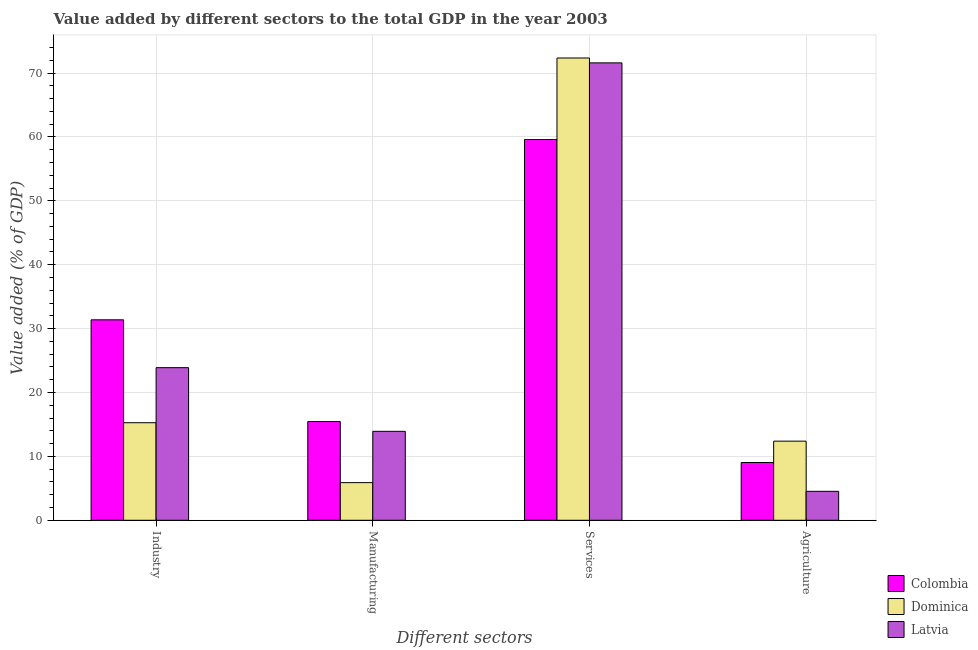How many groups of bars are there?
Your answer should be very brief. 4. How many bars are there on the 4th tick from the right?
Provide a short and direct response. 3. What is the label of the 3rd group of bars from the left?
Provide a short and direct response. Services. What is the value added by manufacturing sector in Dominica?
Give a very brief answer. 5.89. Across all countries, what is the maximum value added by services sector?
Your answer should be very brief. 72.35. Across all countries, what is the minimum value added by services sector?
Make the answer very short. 59.59. In which country was the value added by manufacturing sector maximum?
Your answer should be very brief. Colombia. In which country was the value added by manufacturing sector minimum?
Your response must be concise. Dominica. What is the total value added by manufacturing sector in the graph?
Offer a very short reply. 35.26. What is the difference between the value added by agricultural sector in Colombia and that in Dominica?
Your answer should be very brief. -3.34. What is the difference between the value added by services sector in Latvia and the value added by industrial sector in Colombia?
Your response must be concise. 40.21. What is the average value added by industrial sector per country?
Give a very brief answer. 23.51. What is the difference between the value added by services sector and value added by agricultural sector in Colombia?
Provide a succinct answer. 50.55. What is the ratio of the value added by agricultural sector in Colombia to that in Latvia?
Your answer should be very brief. 1.99. What is the difference between the highest and the second highest value added by services sector?
Make the answer very short. 0.76. What is the difference between the highest and the lowest value added by agricultural sector?
Ensure brevity in your answer.  7.85. In how many countries, is the value added by industrial sector greater than the average value added by industrial sector taken over all countries?
Give a very brief answer. 2. Is the sum of the value added by manufacturing sector in Colombia and Dominica greater than the maximum value added by agricultural sector across all countries?
Keep it short and to the point. Yes. What does the 2nd bar from the left in Industry represents?
Provide a short and direct response. Dominica. What does the 2nd bar from the right in Agriculture represents?
Make the answer very short. Dominica. Is it the case that in every country, the sum of the value added by industrial sector and value added by manufacturing sector is greater than the value added by services sector?
Give a very brief answer. No. How many bars are there?
Your answer should be very brief. 12. How many countries are there in the graph?
Provide a succinct answer. 3. What is the difference between two consecutive major ticks on the Y-axis?
Give a very brief answer. 10. Are the values on the major ticks of Y-axis written in scientific E-notation?
Ensure brevity in your answer.  No. Does the graph contain any zero values?
Offer a terse response. No. Does the graph contain grids?
Your answer should be compact. Yes. Where does the legend appear in the graph?
Your response must be concise. Bottom right. What is the title of the graph?
Provide a short and direct response. Value added by different sectors to the total GDP in the year 2003. Does "Lao PDR" appear as one of the legend labels in the graph?
Provide a succinct answer. No. What is the label or title of the X-axis?
Offer a terse response. Different sectors. What is the label or title of the Y-axis?
Keep it short and to the point. Value added (% of GDP). What is the Value added (% of GDP) of Colombia in Industry?
Give a very brief answer. 31.37. What is the Value added (% of GDP) of Dominica in Industry?
Your response must be concise. 15.27. What is the Value added (% of GDP) in Latvia in Industry?
Keep it short and to the point. 23.88. What is the Value added (% of GDP) in Colombia in Manufacturing?
Your answer should be very brief. 15.45. What is the Value added (% of GDP) of Dominica in Manufacturing?
Offer a terse response. 5.89. What is the Value added (% of GDP) in Latvia in Manufacturing?
Your answer should be compact. 13.92. What is the Value added (% of GDP) of Colombia in Services?
Provide a short and direct response. 59.59. What is the Value added (% of GDP) in Dominica in Services?
Your answer should be very brief. 72.35. What is the Value added (% of GDP) of Latvia in Services?
Your answer should be very brief. 71.59. What is the Value added (% of GDP) of Colombia in Agriculture?
Provide a short and direct response. 9.04. What is the Value added (% of GDP) in Dominica in Agriculture?
Make the answer very short. 12.38. What is the Value added (% of GDP) in Latvia in Agriculture?
Give a very brief answer. 4.53. Across all Different sectors, what is the maximum Value added (% of GDP) in Colombia?
Provide a succinct answer. 59.59. Across all Different sectors, what is the maximum Value added (% of GDP) in Dominica?
Give a very brief answer. 72.35. Across all Different sectors, what is the maximum Value added (% of GDP) of Latvia?
Offer a terse response. 71.59. Across all Different sectors, what is the minimum Value added (% of GDP) in Colombia?
Offer a very short reply. 9.04. Across all Different sectors, what is the minimum Value added (% of GDP) in Dominica?
Offer a terse response. 5.89. Across all Different sectors, what is the minimum Value added (% of GDP) of Latvia?
Your answer should be very brief. 4.53. What is the total Value added (% of GDP) of Colombia in the graph?
Your answer should be compact. 115.45. What is the total Value added (% of GDP) of Dominica in the graph?
Give a very brief answer. 105.89. What is the total Value added (% of GDP) of Latvia in the graph?
Provide a succinct answer. 113.92. What is the difference between the Value added (% of GDP) in Colombia in Industry and that in Manufacturing?
Provide a short and direct response. 15.92. What is the difference between the Value added (% of GDP) of Dominica in Industry and that in Manufacturing?
Your answer should be compact. 9.38. What is the difference between the Value added (% of GDP) in Latvia in Industry and that in Manufacturing?
Your answer should be very brief. 9.97. What is the difference between the Value added (% of GDP) of Colombia in Industry and that in Services?
Ensure brevity in your answer.  -28.22. What is the difference between the Value added (% of GDP) in Dominica in Industry and that in Services?
Keep it short and to the point. -57.08. What is the difference between the Value added (% of GDP) of Latvia in Industry and that in Services?
Make the answer very short. -47.7. What is the difference between the Value added (% of GDP) in Colombia in Industry and that in Agriculture?
Your response must be concise. 22.33. What is the difference between the Value added (% of GDP) of Dominica in Industry and that in Agriculture?
Keep it short and to the point. 2.88. What is the difference between the Value added (% of GDP) in Latvia in Industry and that in Agriculture?
Provide a short and direct response. 19.35. What is the difference between the Value added (% of GDP) in Colombia in Manufacturing and that in Services?
Your answer should be compact. -44.14. What is the difference between the Value added (% of GDP) in Dominica in Manufacturing and that in Services?
Offer a very short reply. -66.46. What is the difference between the Value added (% of GDP) in Latvia in Manufacturing and that in Services?
Your answer should be very brief. -57.67. What is the difference between the Value added (% of GDP) of Colombia in Manufacturing and that in Agriculture?
Give a very brief answer. 6.41. What is the difference between the Value added (% of GDP) of Dominica in Manufacturing and that in Agriculture?
Offer a very short reply. -6.49. What is the difference between the Value added (% of GDP) in Latvia in Manufacturing and that in Agriculture?
Make the answer very short. 9.39. What is the difference between the Value added (% of GDP) of Colombia in Services and that in Agriculture?
Provide a succinct answer. 50.55. What is the difference between the Value added (% of GDP) of Dominica in Services and that in Agriculture?
Offer a terse response. 59.97. What is the difference between the Value added (% of GDP) of Latvia in Services and that in Agriculture?
Make the answer very short. 67.05. What is the difference between the Value added (% of GDP) in Colombia in Industry and the Value added (% of GDP) in Dominica in Manufacturing?
Make the answer very short. 25.48. What is the difference between the Value added (% of GDP) in Colombia in Industry and the Value added (% of GDP) in Latvia in Manufacturing?
Give a very brief answer. 17.45. What is the difference between the Value added (% of GDP) in Dominica in Industry and the Value added (% of GDP) in Latvia in Manufacturing?
Keep it short and to the point. 1.35. What is the difference between the Value added (% of GDP) in Colombia in Industry and the Value added (% of GDP) in Dominica in Services?
Provide a short and direct response. -40.98. What is the difference between the Value added (% of GDP) in Colombia in Industry and the Value added (% of GDP) in Latvia in Services?
Provide a succinct answer. -40.21. What is the difference between the Value added (% of GDP) of Dominica in Industry and the Value added (% of GDP) of Latvia in Services?
Keep it short and to the point. -56.32. What is the difference between the Value added (% of GDP) of Colombia in Industry and the Value added (% of GDP) of Dominica in Agriculture?
Your answer should be compact. 18.99. What is the difference between the Value added (% of GDP) of Colombia in Industry and the Value added (% of GDP) of Latvia in Agriculture?
Ensure brevity in your answer.  26.84. What is the difference between the Value added (% of GDP) in Dominica in Industry and the Value added (% of GDP) in Latvia in Agriculture?
Make the answer very short. 10.73. What is the difference between the Value added (% of GDP) of Colombia in Manufacturing and the Value added (% of GDP) of Dominica in Services?
Offer a very short reply. -56.9. What is the difference between the Value added (% of GDP) of Colombia in Manufacturing and the Value added (% of GDP) of Latvia in Services?
Provide a succinct answer. -56.13. What is the difference between the Value added (% of GDP) in Dominica in Manufacturing and the Value added (% of GDP) in Latvia in Services?
Keep it short and to the point. -65.7. What is the difference between the Value added (% of GDP) of Colombia in Manufacturing and the Value added (% of GDP) of Dominica in Agriculture?
Offer a very short reply. 3.07. What is the difference between the Value added (% of GDP) of Colombia in Manufacturing and the Value added (% of GDP) of Latvia in Agriculture?
Provide a short and direct response. 10.92. What is the difference between the Value added (% of GDP) of Dominica in Manufacturing and the Value added (% of GDP) of Latvia in Agriculture?
Your response must be concise. 1.36. What is the difference between the Value added (% of GDP) of Colombia in Services and the Value added (% of GDP) of Dominica in Agriculture?
Make the answer very short. 47.21. What is the difference between the Value added (% of GDP) in Colombia in Services and the Value added (% of GDP) in Latvia in Agriculture?
Provide a succinct answer. 55.06. What is the difference between the Value added (% of GDP) in Dominica in Services and the Value added (% of GDP) in Latvia in Agriculture?
Offer a very short reply. 67.82. What is the average Value added (% of GDP) in Colombia per Different sectors?
Provide a short and direct response. 28.86. What is the average Value added (% of GDP) in Dominica per Different sectors?
Your answer should be very brief. 26.47. What is the average Value added (% of GDP) of Latvia per Different sectors?
Your answer should be compact. 28.48. What is the difference between the Value added (% of GDP) in Colombia and Value added (% of GDP) in Dominica in Industry?
Your answer should be very brief. 16.1. What is the difference between the Value added (% of GDP) in Colombia and Value added (% of GDP) in Latvia in Industry?
Your response must be concise. 7.49. What is the difference between the Value added (% of GDP) in Dominica and Value added (% of GDP) in Latvia in Industry?
Provide a succinct answer. -8.62. What is the difference between the Value added (% of GDP) of Colombia and Value added (% of GDP) of Dominica in Manufacturing?
Offer a terse response. 9.56. What is the difference between the Value added (% of GDP) of Colombia and Value added (% of GDP) of Latvia in Manufacturing?
Offer a very short reply. 1.54. What is the difference between the Value added (% of GDP) in Dominica and Value added (% of GDP) in Latvia in Manufacturing?
Make the answer very short. -8.03. What is the difference between the Value added (% of GDP) of Colombia and Value added (% of GDP) of Dominica in Services?
Your response must be concise. -12.76. What is the difference between the Value added (% of GDP) in Colombia and Value added (% of GDP) in Latvia in Services?
Ensure brevity in your answer.  -12. What is the difference between the Value added (% of GDP) of Dominica and Value added (% of GDP) of Latvia in Services?
Ensure brevity in your answer.  0.76. What is the difference between the Value added (% of GDP) of Colombia and Value added (% of GDP) of Dominica in Agriculture?
Provide a short and direct response. -3.34. What is the difference between the Value added (% of GDP) of Colombia and Value added (% of GDP) of Latvia in Agriculture?
Your answer should be compact. 4.51. What is the difference between the Value added (% of GDP) in Dominica and Value added (% of GDP) in Latvia in Agriculture?
Give a very brief answer. 7.85. What is the ratio of the Value added (% of GDP) of Colombia in Industry to that in Manufacturing?
Your response must be concise. 2.03. What is the ratio of the Value added (% of GDP) of Dominica in Industry to that in Manufacturing?
Offer a very short reply. 2.59. What is the ratio of the Value added (% of GDP) of Latvia in Industry to that in Manufacturing?
Make the answer very short. 1.72. What is the ratio of the Value added (% of GDP) of Colombia in Industry to that in Services?
Your answer should be compact. 0.53. What is the ratio of the Value added (% of GDP) in Dominica in Industry to that in Services?
Provide a succinct answer. 0.21. What is the ratio of the Value added (% of GDP) of Latvia in Industry to that in Services?
Provide a short and direct response. 0.33. What is the ratio of the Value added (% of GDP) of Colombia in Industry to that in Agriculture?
Your answer should be compact. 3.47. What is the ratio of the Value added (% of GDP) of Dominica in Industry to that in Agriculture?
Provide a succinct answer. 1.23. What is the ratio of the Value added (% of GDP) in Latvia in Industry to that in Agriculture?
Offer a very short reply. 5.27. What is the ratio of the Value added (% of GDP) of Colombia in Manufacturing to that in Services?
Provide a short and direct response. 0.26. What is the ratio of the Value added (% of GDP) in Dominica in Manufacturing to that in Services?
Your response must be concise. 0.08. What is the ratio of the Value added (% of GDP) in Latvia in Manufacturing to that in Services?
Your answer should be very brief. 0.19. What is the ratio of the Value added (% of GDP) in Colombia in Manufacturing to that in Agriculture?
Your answer should be compact. 1.71. What is the ratio of the Value added (% of GDP) of Dominica in Manufacturing to that in Agriculture?
Offer a terse response. 0.48. What is the ratio of the Value added (% of GDP) in Latvia in Manufacturing to that in Agriculture?
Make the answer very short. 3.07. What is the ratio of the Value added (% of GDP) in Colombia in Services to that in Agriculture?
Your answer should be compact. 6.59. What is the ratio of the Value added (% of GDP) in Dominica in Services to that in Agriculture?
Give a very brief answer. 5.84. What is the ratio of the Value added (% of GDP) of Latvia in Services to that in Agriculture?
Your answer should be very brief. 15.8. What is the difference between the highest and the second highest Value added (% of GDP) of Colombia?
Your response must be concise. 28.22. What is the difference between the highest and the second highest Value added (% of GDP) of Dominica?
Offer a very short reply. 57.08. What is the difference between the highest and the second highest Value added (% of GDP) in Latvia?
Provide a short and direct response. 47.7. What is the difference between the highest and the lowest Value added (% of GDP) of Colombia?
Ensure brevity in your answer.  50.55. What is the difference between the highest and the lowest Value added (% of GDP) in Dominica?
Your response must be concise. 66.46. What is the difference between the highest and the lowest Value added (% of GDP) in Latvia?
Your answer should be very brief. 67.05. 